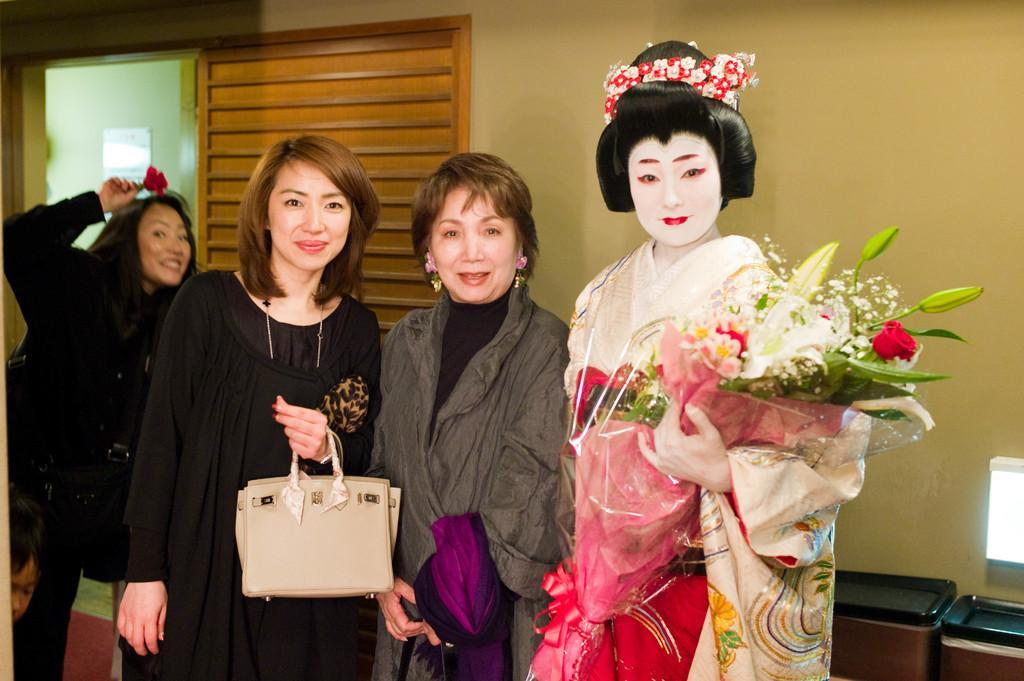Please provide a concise description of this image. In this picture there are three women in the center. Towards the left there is a woman in black dress and she is holding a cream bag. Beside her there is another woman wearing a grey jacket. Towards the right there is a woman wearing a Chinese costume, makeup and holding a bouquet. Towards the left there are two persons. In the background there is a wall with a door. 